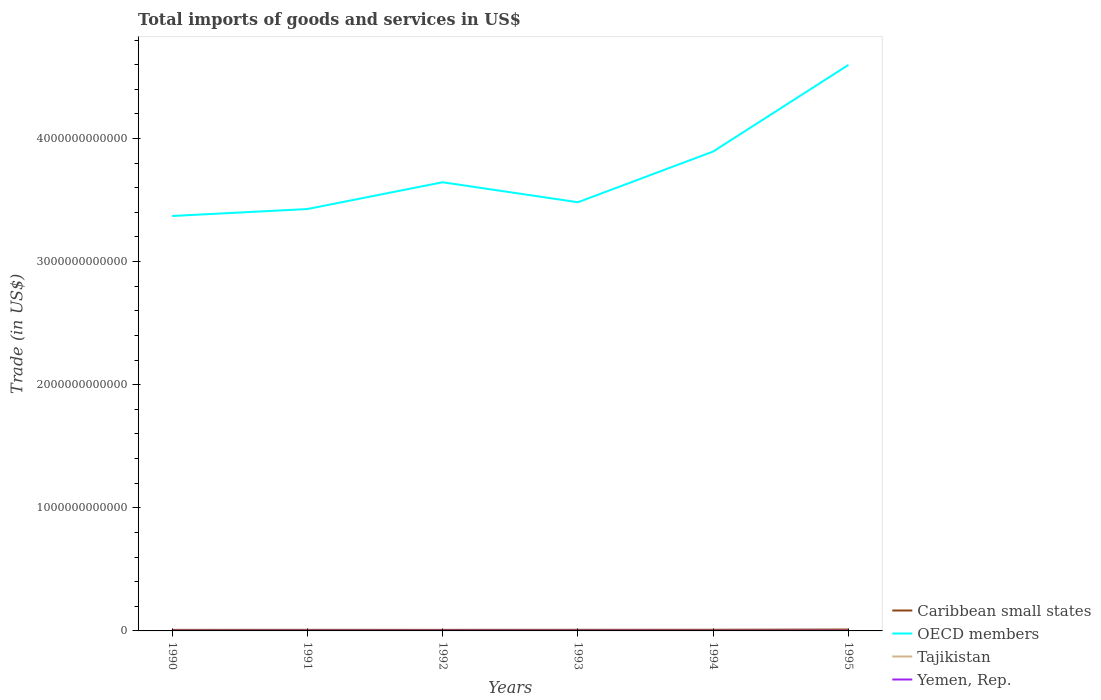Across all years, what is the maximum total imports of goods and services in OECD members?
Your answer should be very brief. 3.37e+12. What is the total total imports of goods and services in Yemen, Rep. in the graph?
Your answer should be compact. 1.48e+08. What is the difference between the highest and the second highest total imports of goods and services in Tajikistan?
Your response must be concise. 6.85e+08. Is the total imports of goods and services in Tajikistan strictly greater than the total imports of goods and services in Caribbean small states over the years?
Your response must be concise. Yes. How many lines are there?
Your answer should be very brief. 4. How many years are there in the graph?
Your answer should be compact. 6. What is the difference between two consecutive major ticks on the Y-axis?
Offer a terse response. 1.00e+12. Are the values on the major ticks of Y-axis written in scientific E-notation?
Ensure brevity in your answer.  No. Does the graph contain any zero values?
Your answer should be very brief. No. Where does the legend appear in the graph?
Keep it short and to the point. Bottom right. How many legend labels are there?
Keep it short and to the point. 4. How are the legend labels stacked?
Your answer should be very brief. Vertical. What is the title of the graph?
Give a very brief answer. Total imports of goods and services in US$. What is the label or title of the X-axis?
Give a very brief answer. Years. What is the label or title of the Y-axis?
Offer a terse response. Trade (in US$). What is the Trade (in US$) in Caribbean small states in 1990?
Offer a very short reply. 8.47e+09. What is the Trade (in US$) of OECD members in 1990?
Give a very brief answer. 3.37e+12. What is the Trade (in US$) in Tajikistan in 1990?
Your answer should be very brief. 9.25e+08. What is the Trade (in US$) of Yemen, Rep. in 1990?
Offer a very short reply. 9.69e+08. What is the Trade (in US$) in Caribbean small states in 1991?
Make the answer very short. 8.66e+09. What is the Trade (in US$) of OECD members in 1991?
Offer a terse response. 3.43e+12. What is the Trade (in US$) in Tajikistan in 1991?
Your answer should be very brief. 8.17e+08. What is the Trade (in US$) in Yemen, Rep. in 1991?
Give a very brief answer. 1.79e+09. What is the Trade (in US$) in Caribbean small states in 1992?
Give a very brief answer. 8.45e+09. What is the Trade (in US$) of OECD members in 1992?
Offer a terse response. 3.64e+12. What is the Trade (in US$) of Tajikistan in 1992?
Your answer should be very brief. 2.40e+08. What is the Trade (in US$) of Yemen, Rep. in 1992?
Make the answer very short. 1.94e+09. What is the Trade (in US$) in Caribbean small states in 1993?
Provide a short and direct response. 8.96e+09. What is the Trade (in US$) in OECD members in 1993?
Make the answer very short. 3.48e+12. What is the Trade (in US$) of Tajikistan in 1993?
Provide a short and direct response. 6.86e+08. What is the Trade (in US$) in Yemen, Rep. in 1993?
Offer a terse response. 2.05e+09. What is the Trade (in US$) of Caribbean small states in 1994?
Make the answer very short. 9.38e+09. What is the Trade (in US$) of OECD members in 1994?
Your response must be concise. 3.89e+12. What is the Trade (in US$) of Tajikistan in 1994?
Provide a succinct answer. 7.35e+08. What is the Trade (in US$) of Yemen, Rep. in 1994?
Ensure brevity in your answer.  1.22e+09. What is the Trade (in US$) of Caribbean small states in 1995?
Provide a short and direct response. 1.14e+1. What is the Trade (in US$) in OECD members in 1995?
Keep it short and to the point. 4.60e+12. What is the Trade (in US$) of Tajikistan in 1995?
Your answer should be very brief. 8.86e+08. What is the Trade (in US$) in Yemen, Rep. in 1995?
Your response must be concise. 1.79e+09. Across all years, what is the maximum Trade (in US$) in Caribbean small states?
Your answer should be compact. 1.14e+1. Across all years, what is the maximum Trade (in US$) of OECD members?
Offer a terse response. 4.60e+12. Across all years, what is the maximum Trade (in US$) of Tajikistan?
Provide a succinct answer. 9.25e+08. Across all years, what is the maximum Trade (in US$) of Yemen, Rep.?
Your answer should be compact. 2.05e+09. Across all years, what is the minimum Trade (in US$) of Caribbean small states?
Provide a succinct answer. 8.45e+09. Across all years, what is the minimum Trade (in US$) of OECD members?
Your response must be concise. 3.37e+12. Across all years, what is the minimum Trade (in US$) in Tajikistan?
Offer a very short reply. 2.40e+08. Across all years, what is the minimum Trade (in US$) in Yemen, Rep.?
Provide a short and direct response. 9.69e+08. What is the total Trade (in US$) of Caribbean small states in the graph?
Make the answer very short. 5.53e+1. What is the total Trade (in US$) of OECD members in the graph?
Ensure brevity in your answer.  2.24e+13. What is the total Trade (in US$) in Tajikistan in the graph?
Provide a succinct answer. 4.29e+09. What is the total Trade (in US$) in Yemen, Rep. in the graph?
Provide a short and direct response. 9.75e+09. What is the difference between the Trade (in US$) of Caribbean small states in 1990 and that in 1991?
Your answer should be compact. -1.87e+08. What is the difference between the Trade (in US$) in OECD members in 1990 and that in 1991?
Keep it short and to the point. -5.65e+1. What is the difference between the Trade (in US$) in Tajikistan in 1990 and that in 1991?
Your answer should be compact. 1.08e+08. What is the difference between the Trade (in US$) of Yemen, Rep. in 1990 and that in 1991?
Make the answer very short. -8.25e+08. What is the difference between the Trade (in US$) of Caribbean small states in 1990 and that in 1992?
Make the answer very short. 1.64e+07. What is the difference between the Trade (in US$) of OECD members in 1990 and that in 1992?
Provide a succinct answer. -2.74e+11. What is the difference between the Trade (in US$) of Tajikistan in 1990 and that in 1992?
Your response must be concise. 6.85e+08. What is the difference between the Trade (in US$) in Yemen, Rep. in 1990 and that in 1992?
Your answer should be compact. -9.66e+08. What is the difference between the Trade (in US$) in Caribbean small states in 1990 and that in 1993?
Offer a terse response. -4.91e+08. What is the difference between the Trade (in US$) of OECD members in 1990 and that in 1993?
Your response must be concise. -1.12e+11. What is the difference between the Trade (in US$) in Tajikistan in 1990 and that in 1993?
Keep it short and to the point. 2.39e+08. What is the difference between the Trade (in US$) in Yemen, Rep. in 1990 and that in 1993?
Ensure brevity in your answer.  -1.08e+09. What is the difference between the Trade (in US$) of Caribbean small states in 1990 and that in 1994?
Give a very brief answer. -9.08e+08. What is the difference between the Trade (in US$) in OECD members in 1990 and that in 1994?
Your answer should be compact. -5.24e+11. What is the difference between the Trade (in US$) in Tajikistan in 1990 and that in 1994?
Your answer should be very brief. 1.90e+08. What is the difference between the Trade (in US$) of Yemen, Rep. in 1990 and that in 1994?
Your answer should be compact. -2.47e+08. What is the difference between the Trade (in US$) in Caribbean small states in 1990 and that in 1995?
Ensure brevity in your answer.  -2.92e+09. What is the difference between the Trade (in US$) in OECD members in 1990 and that in 1995?
Make the answer very short. -1.23e+12. What is the difference between the Trade (in US$) of Tajikistan in 1990 and that in 1995?
Provide a short and direct response. 3.91e+07. What is the difference between the Trade (in US$) of Yemen, Rep. in 1990 and that in 1995?
Your answer should be compact. -8.18e+08. What is the difference between the Trade (in US$) in Caribbean small states in 1991 and that in 1992?
Provide a short and direct response. 2.03e+08. What is the difference between the Trade (in US$) in OECD members in 1991 and that in 1992?
Offer a very short reply. -2.18e+11. What is the difference between the Trade (in US$) in Tajikistan in 1991 and that in 1992?
Provide a succinct answer. 5.77e+08. What is the difference between the Trade (in US$) in Yemen, Rep. in 1991 and that in 1992?
Ensure brevity in your answer.  -1.41e+08. What is the difference between the Trade (in US$) of Caribbean small states in 1991 and that in 1993?
Make the answer very short. -3.04e+08. What is the difference between the Trade (in US$) of OECD members in 1991 and that in 1993?
Make the answer very short. -5.52e+1. What is the difference between the Trade (in US$) of Tajikistan in 1991 and that in 1993?
Offer a terse response. 1.31e+08. What is the difference between the Trade (in US$) in Yemen, Rep. in 1991 and that in 1993?
Provide a short and direct response. -2.58e+08. What is the difference between the Trade (in US$) in Caribbean small states in 1991 and that in 1994?
Give a very brief answer. -7.22e+08. What is the difference between the Trade (in US$) in OECD members in 1991 and that in 1994?
Give a very brief answer. -4.67e+11. What is the difference between the Trade (in US$) in Tajikistan in 1991 and that in 1994?
Your answer should be compact. 8.19e+07. What is the difference between the Trade (in US$) of Yemen, Rep. in 1991 and that in 1994?
Provide a succinct answer. 5.77e+08. What is the difference between the Trade (in US$) in Caribbean small states in 1991 and that in 1995?
Your response must be concise. -2.73e+09. What is the difference between the Trade (in US$) of OECD members in 1991 and that in 1995?
Offer a terse response. -1.17e+12. What is the difference between the Trade (in US$) in Tajikistan in 1991 and that in 1995?
Your answer should be compact. -6.88e+07. What is the difference between the Trade (in US$) in Yemen, Rep. in 1991 and that in 1995?
Offer a very short reply. 6.89e+06. What is the difference between the Trade (in US$) of Caribbean small states in 1992 and that in 1993?
Give a very brief answer. -5.07e+08. What is the difference between the Trade (in US$) of OECD members in 1992 and that in 1993?
Your answer should be very brief. 1.62e+11. What is the difference between the Trade (in US$) of Tajikistan in 1992 and that in 1993?
Your answer should be very brief. -4.46e+08. What is the difference between the Trade (in US$) of Yemen, Rep. in 1992 and that in 1993?
Provide a short and direct response. -1.16e+08. What is the difference between the Trade (in US$) in Caribbean small states in 1992 and that in 1994?
Offer a terse response. -9.25e+08. What is the difference between the Trade (in US$) in OECD members in 1992 and that in 1994?
Give a very brief answer. -2.50e+11. What is the difference between the Trade (in US$) in Tajikistan in 1992 and that in 1994?
Provide a short and direct response. -4.96e+08. What is the difference between the Trade (in US$) in Yemen, Rep. in 1992 and that in 1994?
Your answer should be very brief. 7.19e+08. What is the difference between the Trade (in US$) in Caribbean small states in 1992 and that in 1995?
Keep it short and to the point. -2.93e+09. What is the difference between the Trade (in US$) in OECD members in 1992 and that in 1995?
Your answer should be compact. -9.53e+11. What is the difference between the Trade (in US$) of Tajikistan in 1992 and that in 1995?
Provide a succinct answer. -6.46e+08. What is the difference between the Trade (in US$) of Yemen, Rep. in 1992 and that in 1995?
Make the answer very short. 1.48e+08. What is the difference between the Trade (in US$) of Caribbean small states in 1993 and that in 1994?
Offer a terse response. -4.17e+08. What is the difference between the Trade (in US$) of OECD members in 1993 and that in 1994?
Make the answer very short. -4.12e+11. What is the difference between the Trade (in US$) of Tajikistan in 1993 and that in 1994?
Offer a terse response. -4.95e+07. What is the difference between the Trade (in US$) in Yemen, Rep. in 1993 and that in 1994?
Provide a succinct answer. 8.35e+08. What is the difference between the Trade (in US$) in Caribbean small states in 1993 and that in 1995?
Offer a very short reply. -2.42e+09. What is the difference between the Trade (in US$) in OECD members in 1993 and that in 1995?
Offer a very short reply. -1.12e+12. What is the difference between the Trade (in US$) of Tajikistan in 1993 and that in 1995?
Your response must be concise. -2.00e+08. What is the difference between the Trade (in US$) of Yemen, Rep. in 1993 and that in 1995?
Your answer should be compact. 2.64e+08. What is the difference between the Trade (in US$) of Caribbean small states in 1994 and that in 1995?
Ensure brevity in your answer.  -2.01e+09. What is the difference between the Trade (in US$) of OECD members in 1994 and that in 1995?
Keep it short and to the point. -7.04e+11. What is the difference between the Trade (in US$) in Tajikistan in 1994 and that in 1995?
Make the answer very short. -1.51e+08. What is the difference between the Trade (in US$) of Yemen, Rep. in 1994 and that in 1995?
Ensure brevity in your answer.  -5.71e+08. What is the difference between the Trade (in US$) of Caribbean small states in 1990 and the Trade (in US$) of OECD members in 1991?
Make the answer very short. -3.42e+12. What is the difference between the Trade (in US$) of Caribbean small states in 1990 and the Trade (in US$) of Tajikistan in 1991?
Offer a terse response. 7.65e+09. What is the difference between the Trade (in US$) of Caribbean small states in 1990 and the Trade (in US$) of Yemen, Rep. in 1991?
Your response must be concise. 6.68e+09. What is the difference between the Trade (in US$) in OECD members in 1990 and the Trade (in US$) in Tajikistan in 1991?
Make the answer very short. 3.37e+12. What is the difference between the Trade (in US$) in OECD members in 1990 and the Trade (in US$) in Yemen, Rep. in 1991?
Ensure brevity in your answer.  3.37e+12. What is the difference between the Trade (in US$) of Tajikistan in 1990 and the Trade (in US$) of Yemen, Rep. in 1991?
Your answer should be compact. -8.69e+08. What is the difference between the Trade (in US$) of Caribbean small states in 1990 and the Trade (in US$) of OECD members in 1992?
Your answer should be very brief. -3.64e+12. What is the difference between the Trade (in US$) in Caribbean small states in 1990 and the Trade (in US$) in Tajikistan in 1992?
Ensure brevity in your answer.  8.23e+09. What is the difference between the Trade (in US$) of Caribbean small states in 1990 and the Trade (in US$) of Yemen, Rep. in 1992?
Provide a succinct answer. 6.54e+09. What is the difference between the Trade (in US$) in OECD members in 1990 and the Trade (in US$) in Tajikistan in 1992?
Make the answer very short. 3.37e+12. What is the difference between the Trade (in US$) of OECD members in 1990 and the Trade (in US$) of Yemen, Rep. in 1992?
Provide a short and direct response. 3.37e+12. What is the difference between the Trade (in US$) in Tajikistan in 1990 and the Trade (in US$) in Yemen, Rep. in 1992?
Ensure brevity in your answer.  -1.01e+09. What is the difference between the Trade (in US$) in Caribbean small states in 1990 and the Trade (in US$) in OECD members in 1993?
Give a very brief answer. -3.47e+12. What is the difference between the Trade (in US$) of Caribbean small states in 1990 and the Trade (in US$) of Tajikistan in 1993?
Offer a terse response. 7.79e+09. What is the difference between the Trade (in US$) of Caribbean small states in 1990 and the Trade (in US$) of Yemen, Rep. in 1993?
Offer a very short reply. 6.42e+09. What is the difference between the Trade (in US$) of OECD members in 1990 and the Trade (in US$) of Tajikistan in 1993?
Provide a succinct answer. 3.37e+12. What is the difference between the Trade (in US$) in OECD members in 1990 and the Trade (in US$) in Yemen, Rep. in 1993?
Give a very brief answer. 3.37e+12. What is the difference between the Trade (in US$) of Tajikistan in 1990 and the Trade (in US$) of Yemen, Rep. in 1993?
Keep it short and to the point. -1.13e+09. What is the difference between the Trade (in US$) of Caribbean small states in 1990 and the Trade (in US$) of OECD members in 1994?
Offer a terse response. -3.89e+12. What is the difference between the Trade (in US$) in Caribbean small states in 1990 and the Trade (in US$) in Tajikistan in 1994?
Your response must be concise. 7.74e+09. What is the difference between the Trade (in US$) of Caribbean small states in 1990 and the Trade (in US$) of Yemen, Rep. in 1994?
Provide a succinct answer. 7.26e+09. What is the difference between the Trade (in US$) in OECD members in 1990 and the Trade (in US$) in Tajikistan in 1994?
Make the answer very short. 3.37e+12. What is the difference between the Trade (in US$) in OECD members in 1990 and the Trade (in US$) in Yemen, Rep. in 1994?
Ensure brevity in your answer.  3.37e+12. What is the difference between the Trade (in US$) in Tajikistan in 1990 and the Trade (in US$) in Yemen, Rep. in 1994?
Provide a short and direct response. -2.91e+08. What is the difference between the Trade (in US$) in Caribbean small states in 1990 and the Trade (in US$) in OECD members in 1995?
Your answer should be compact. -4.59e+12. What is the difference between the Trade (in US$) of Caribbean small states in 1990 and the Trade (in US$) of Tajikistan in 1995?
Ensure brevity in your answer.  7.59e+09. What is the difference between the Trade (in US$) in Caribbean small states in 1990 and the Trade (in US$) in Yemen, Rep. in 1995?
Keep it short and to the point. 6.68e+09. What is the difference between the Trade (in US$) in OECD members in 1990 and the Trade (in US$) in Tajikistan in 1995?
Keep it short and to the point. 3.37e+12. What is the difference between the Trade (in US$) of OECD members in 1990 and the Trade (in US$) of Yemen, Rep. in 1995?
Ensure brevity in your answer.  3.37e+12. What is the difference between the Trade (in US$) in Tajikistan in 1990 and the Trade (in US$) in Yemen, Rep. in 1995?
Your answer should be very brief. -8.62e+08. What is the difference between the Trade (in US$) in Caribbean small states in 1991 and the Trade (in US$) in OECD members in 1992?
Give a very brief answer. -3.64e+12. What is the difference between the Trade (in US$) in Caribbean small states in 1991 and the Trade (in US$) in Tajikistan in 1992?
Your answer should be very brief. 8.42e+09. What is the difference between the Trade (in US$) of Caribbean small states in 1991 and the Trade (in US$) of Yemen, Rep. in 1992?
Offer a terse response. 6.72e+09. What is the difference between the Trade (in US$) in OECD members in 1991 and the Trade (in US$) in Tajikistan in 1992?
Your answer should be very brief. 3.43e+12. What is the difference between the Trade (in US$) of OECD members in 1991 and the Trade (in US$) of Yemen, Rep. in 1992?
Keep it short and to the point. 3.43e+12. What is the difference between the Trade (in US$) in Tajikistan in 1991 and the Trade (in US$) in Yemen, Rep. in 1992?
Provide a succinct answer. -1.12e+09. What is the difference between the Trade (in US$) of Caribbean small states in 1991 and the Trade (in US$) of OECD members in 1993?
Keep it short and to the point. -3.47e+12. What is the difference between the Trade (in US$) in Caribbean small states in 1991 and the Trade (in US$) in Tajikistan in 1993?
Offer a very short reply. 7.97e+09. What is the difference between the Trade (in US$) of Caribbean small states in 1991 and the Trade (in US$) of Yemen, Rep. in 1993?
Provide a short and direct response. 6.61e+09. What is the difference between the Trade (in US$) of OECD members in 1991 and the Trade (in US$) of Tajikistan in 1993?
Make the answer very short. 3.43e+12. What is the difference between the Trade (in US$) of OECD members in 1991 and the Trade (in US$) of Yemen, Rep. in 1993?
Ensure brevity in your answer.  3.42e+12. What is the difference between the Trade (in US$) in Tajikistan in 1991 and the Trade (in US$) in Yemen, Rep. in 1993?
Keep it short and to the point. -1.23e+09. What is the difference between the Trade (in US$) in Caribbean small states in 1991 and the Trade (in US$) in OECD members in 1994?
Offer a very short reply. -3.89e+12. What is the difference between the Trade (in US$) of Caribbean small states in 1991 and the Trade (in US$) of Tajikistan in 1994?
Provide a short and direct response. 7.92e+09. What is the difference between the Trade (in US$) in Caribbean small states in 1991 and the Trade (in US$) in Yemen, Rep. in 1994?
Your answer should be compact. 7.44e+09. What is the difference between the Trade (in US$) in OECD members in 1991 and the Trade (in US$) in Tajikistan in 1994?
Offer a very short reply. 3.43e+12. What is the difference between the Trade (in US$) of OECD members in 1991 and the Trade (in US$) of Yemen, Rep. in 1994?
Keep it short and to the point. 3.43e+12. What is the difference between the Trade (in US$) of Tajikistan in 1991 and the Trade (in US$) of Yemen, Rep. in 1994?
Your response must be concise. -3.99e+08. What is the difference between the Trade (in US$) of Caribbean small states in 1991 and the Trade (in US$) of OECD members in 1995?
Your answer should be compact. -4.59e+12. What is the difference between the Trade (in US$) of Caribbean small states in 1991 and the Trade (in US$) of Tajikistan in 1995?
Your answer should be compact. 7.77e+09. What is the difference between the Trade (in US$) in Caribbean small states in 1991 and the Trade (in US$) in Yemen, Rep. in 1995?
Ensure brevity in your answer.  6.87e+09. What is the difference between the Trade (in US$) in OECD members in 1991 and the Trade (in US$) in Tajikistan in 1995?
Provide a succinct answer. 3.43e+12. What is the difference between the Trade (in US$) in OECD members in 1991 and the Trade (in US$) in Yemen, Rep. in 1995?
Ensure brevity in your answer.  3.43e+12. What is the difference between the Trade (in US$) of Tajikistan in 1991 and the Trade (in US$) of Yemen, Rep. in 1995?
Offer a very short reply. -9.70e+08. What is the difference between the Trade (in US$) in Caribbean small states in 1992 and the Trade (in US$) in OECD members in 1993?
Provide a succinct answer. -3.47e+12. What is the difference between the Trade (in US$) in Caribbean small states in 1992 and the Trade (in US$) in Tajikistan in 1993?
Offer a terse response. 7.77e+09. What is the difference between the Trade (in US$) of Caribbean small states in 1992 and the Trade (in US$) of Yemen, Rep. in 1993?
Provide a short and direct response. 6.40e+09. What is the difference between the Trade (in US$) of OECD members in 1992 and the Trade (in US$) of Tajikistan in 1993?
Offer a terse response. 3.64e+12. What is the difference between the Trade (in US$) of OECD members in 1992 and the Trade (in US$) of Yemen, Rep. in 1993?
Your answer should be very brief. 3.64e+12. What is the difference between the Trade (in US$) of Tajikistan in 1992 and the Trade (in US$) of Yemen, Rep. in 1993?
Provide a short and direct response. -1.81e+09. What is the difference between the Trade (in US$) of Caribbean small states in 1992 and the Trade (in US$) of OECD members in 1994?
Your answer should be very brief. -3.89e+12. What is the difference between the Trade (in US$) in Caribbean small states in 1992 and the Trade (in US$) in Tajikistan in 1994?
Offer a very short reply. 7.72e+09. What is the difference between the Trade (in US$) of Caribbean small states in 1992 and the Trade (in US$) of Yemen, Rep. in 1994?
Offer a very short reply. 7.24e+09. What is the difference between the Trade (in US$) of OECD members in 1992 and the Trade (in US$) of Tajikistan in 1994?
Provide a short and direct response. 3.64e+12. What is the difference between the Trade (in US$) in OECD members in 1992 and the Trade (in US$) in Yemen, Rep. in 1994?
Keep it short and to the point. 3.64e+12. What is the difference between the Trade (in US$) of Tajikistan in 1992 and the Trade (in US$) of Yemen, Rep. in 1994?
Offer a very short reply. -9.77e+08. What is the difference between the Trade (in US$) in Caribbean small states in 1992 and the Trade (in US$) in OECD members in 1995?
Ensure brevity in your answer.  -4.59e+12. What is the difference between the Trade (in US$) of Caribbean small states in 1992 and the Trade (in US$) of Tajikistan in 1995?
Offer a terse response. 7.57e+09. What is the difference between the Trade (in US$) in Caribbean small states in 1992 and the Trade (in US$) in Yemen, Rep. in 1995?
Offer a very short reply. 6.67e+09. What is the difference between the Trade (in US$) in OECD members in 1992 and the Trade (in US$) in Tajikistan in 1995?
Provide a short and direct response. 3.64e+12. What is the difference between the Trade (in US$) of OECD members in 1992 and the Trade (in US$) of Yemen, Rep. in 1995?
Your answer should be very brief. 3.64e+12. What is the difference between the Trade (in US$) in Tajikistan in 1992 and the Trade (in US$) in Yemen, Rep. in 1995?
Offer a terse response. -1.55e+09. What is the difference between the Trade (in US$) in Caribbean small states in 1993 and the Trade (in US$) in OECD members in 1994?
Offer a terse response. -3.89e+12. What is the difference between the Trade (in US$) in Caribbean small states in 1993 and the Trade (in US$) in Tajikistan in 1994?
Make the answer very short. 8.23e+09. What is the difference between the Trade (in US$) of Caribbean small states in 1993 and the Trade (in US$) of Yemen, Rep. in 1994?
Give a very brief answer. 7.75e+09. What is the difference between the Trade (in US$) in OECD members in 1993 and the Trade (in US$) in Tajikistan in 1994?
Your response must be concise. 3.48e+12. What is the difference between the Trade (in US$) of OECD members in 1993 and the Trade (in US$) of Yemen, Rep. in 1994?
Your answer should be compact. 3.48e+12. What is the difference between the Trade (in US$) of Tajikistan in 1993 and the Trade (in US$) of Yemen, Rep. in 1994?
Keep it short and to the point. -5.31e+08. What is the difference between the Trade (in US$) of Caribbean small states in 1993 and the Trade (in US$) of OECD members in 1995?
Provide a succinct answer. -4.59e+12. What is the difference between the Trade (in US$) of Caribbean small states in 1993 and the Trade (in US$) of Tajikistan in 1995?
Keep it short and to the point. 8.08e+09. What is the difference between the Trade (in US$) in Caribbean small states in 1993 and the Trade (in US$) in Yemen, Rep. in 1995?
Give a very brief answer. 7.18e+09. What is the difference between the Trade (in US$) in OECD members in 1993 and the Trade (in US$) in Tajikistan in 1995?
Provide a short and direct response. 3.48e+12. What is the difference between the Trade (in US$) of OECD members in 1993 and the Trade (in US$) of Yemen, Rep. in 1995?
Your response must be concise. 3.48e+12. What is the difference between the Trade (in US$) of Tajikistan in 1993 and the Trade (in US$) of Yemen, Rep. in 1995?
Offer a terse response. -1.10e+09. What is the difference between the Trade (in US$) in Caribbean small states in 1994 and the Trade (in US$) in OECD members in 1995?
Your response must be concise. -4.59e+12. What is the difference between the Trade (in US$) in Caribbean small states in 1994 and the Trade (in US$) in Tajikistan in 1995?
Your response must be concise. 8.49e+09. What is the difference between the Trade (in US$) in Caribbean small states in 1994 and the Trade (in US$) in Yemen, Rep. in 1995?
Your response must be concise. 7.59e+09. What is the difference between the Trade (in US$) of OECD members in 1994 and the Trade (in US$) of Tajikistan in 1995?
Ensure brevity in your answer.  3.89e+12. What is the difference between the Trade (in US$) in OECD members in 1994 and the Trade (in US$) in Yemen, Rep. in 1995?
Offer a terse response. 3.89e+12. What is the difference between the Trade (in US$) in Tajikistan in 1994 and the Trade (in US$) in Yemen, Rep. in 1995?
Your answer should be very brief. -1.05e+09. What is the average Trade (in US$) in Caribbean small states per year?
Provide a succinct answer. 9.22e+09. What is the average Trade (in US$) in OECD members per year?
Offer a very short reply. 3.74e+12. What is the average Trade (in US$) of Tajikistan per year?
Keep it short and to the point. 7.15e+08. What is the average Trade (in US$) in Yemen, Rep. per year?
Provide a short and direct response. 1.63e+09. In the year 1990, what is the difference between the Trade (in US$) of Caribbean small states and Trade (in US$) of OECD members?
Provide a succinct answer. -3.36e+12. In the year 1990, what is the difference between the Trade (in US$) of Caribbean small states and Trade (in US$) of Tajikistan?
Your response must be concise. 7.55e+09. In the year 1990, what is the difference between the Trade (in US$) of Caribbean small states and Trade (in US$) of Yemen, Rep.?
Your response must be concise. 7.50e+09. In the year 1990, what is the difference between the Trade (in US$) of OECD members and Trade (in US$) of Tajikistan?
Your answer should be very brief. 3.37e+12. In the year 1990, what is the difference between the Trade (in US$) of OECD members and Trade (in US$) of Yemen, Rep.?
Make the answer very short. 3.37e+12. In the year 1990, what is the difference between the Trade (in US$) of Tajikistan and Trade (in US$) of Yemen, Rep.?
Your answer should be very brief. -4.42e+07. In the year 1991, what is the difference between the Trade (in US$) of Caribbean small states and Trade (in US$) of OECD members?
Make the answer very short. -3.42e+12. In the year 1991, what is the difference between the Trade (in US$) of Caribbean small states and Trade (in US$) of Tajikistan?
Provide a short and direct response. 7.84e+09. In the year 1991, what is the difference between the Trade (in US$) of Caribbean small states and Trade (in US$) of Yemen, Rep.?
Provide a succinct answer. 6.86e+09. In the year 1991, what is the difference between the Trade (in US$) of OECD members and Trade (in US$) of Tajikistan?
Give a very brief answer. 3.43e+12. In the year 1991, what is the difference between the Trade (in US$) of OECD members and Trade (in US$) of Yemen, Rep.?
Your answer should be very brief. 3.43e+12. In the year 1991, what is the difference between the Trade (in US$) in Tajikistan and Trade (in US$) in Yemen, Rep.?
Give a very brief answer. -9.77e+08. In the year 1992, what is the difference between the Trade (in US$) in Caribbean small states and Trade (in US$) in OECD members?
Ensure brevity in your answer.  -3.64e+12. In the year 1992, what is the difference between the Trade (in US$) in Caribbean small states and Trade (in US$) in Tajikistan?
Make the answer very short. 8.22e+09. In the year 1992, what is the difference between the Trade (in US$) in Caribbean small states and Trade (in US$) in Yemen, Rep.?
Provide a succinct answer. 6.52e+09. In the year 1992, what is the difference between the Trade (in US$) in OECD members and Trade (in US$) in Tajikistan?
Offer a very short reply. 3.64e+12. In the year 1992, what is the difference between the Trade (in US$) of OECD members and Trade (in US$) of Yemen, Rep.?
Give a very brief answer. 3.64e+12. In the year 1992, what is the difference between the Trade (in US$) of Tajikistan and Trade (in US$) of Yemen, Rep.?
Make the answer very short. -1.70e+09. In the year 1993, what is the difference between the Trade (in US$) of Caribbean small states and Trade (in US$) of OECD members?
Keep it short and to the point. -3.47e+12. In the year 1993, what is the difference between the Trade (in US$) of Caribbean small states and Trade (in US$) of Tajikistan?
Give a very brief answer. 8.28e+09. In the year 1993, what is the difference between the Trade (in US$) of Caribbean small states and Trade (in US$) of Yemen, Rep.?
Your answer should be very brief. 6.91e+09. In the year 1993, what is the difference between the Trade (in US$) in OECD members and Trade (in US$) in Tajikistan?
Your answer should be compact. 3.48e+12. In the year 1993, what is the difference between the Trade (in US$) of OECD members and Trade (in US$) of Yemen, Rep.?
Your answer should be compact. 3.48e+12. In the year 1993, what is the difference between the Trade (in US$) in Tajikistan and Trade (in US$) in Yemen, Rep.?
Provide a succinct answer. -1.37e+09. In the year 1994, what is the difference between the Trade (in US$) in Caribbean small states and Trade (in US$) in OECD members?
Provide a short and direct response. -3.89e+12. In the year 1994, what is the difference between the Trade (in US$) in Caribbean small states and Trade (in US$) in Tajikistan?
Your answer should be compact. 8.64e+09. In the year 1994, what is the difference between the Trade (in US$) of Caribbean small states and Trade (in US$) of Yemen, Rep.?
Make the answer very short. 8.16e+09. In the year 1994, what is the difference between the Trade (in US$) in OECD members and Trade (in US$) in Tajikistan?
Give a very brief answer. 3.89e+12. In the year 1994, what is the difference between the Trade (in US$) of OECD members and Trade (in US$) of Yemen, Rep.?
Provide a short and direct response. 3.89e+12. In the year 1994, what is the difference between the Trade (in US$) of Tajikistan and Trade (in US$) of Yemen, Rep.?
Your answer should be compact. -4.81e+08. In the year 1995, what is the difference between the Trade (in US$) of Caribbean small states and Trade (in US$) of OECD members?
Provide a succinct answer. -4.59e+12. In the year 1995, what is the difference between the Trade (in US$) in Caribbean small states and Trade (in US$) in Tajikistan?
Your answer should be compact. 1.05e+1. In the year 1995, what is the difference between the Trade (in US$) of Caribbean small states and Trade (in US$) of Yemen, Rep.?
Offer a terse response. 9.60e+09. In the year 1995, what is the difference between the Trade (in US$) in OECD members and Trade (in US$) in Tajikistan?
Your answer should be very brief. 4.60e+12. In the year 1995, what is the difference between the Trade (in US$) in OECD members and Trade (in US$) in Yemen, Rep.?
Your answer should be compact. 4.60e+12. In the year 1995, what is the difference between the Trade (in US$) of Tajikistan and Trade (in US$) of Yemen, Rep.?
Keep it short and to the point. -9.01e+08. What is the ratio of the Trade (in US$) of Caribbean small states in 1990 to that in 1991?
Your answer should be compact. 0.98. What is the ratio of the Trade (in US$) of OECD members in 1990 to that in 1991?
Offer a terse response. 0.98. What is the ratio of the Trade (in US$) in Tajikistan in 1990 to that in 1991?
Make the answer very short. 1.13. What is the ratio of the Trade (in US$) of Yemen, Rep. in 1990 to that in 1991?
Ensure brevity in your answer.  0.54. What is the ratio of the Trade (in US$) in Caribbean small states in 1990 to that in 1992?
Provide a short and direct response. 1. What is the ratio of the Trade (in US$) of OECD members in 1990 to that in 1992?
Keep it short and to the point. 0.92. What is the ratio of the Trade (in US$) in Tajikistan in 1990 to that in 1992?
Provide a succinct answer. 3.86. What is the ratio of the Trade (in US$) in Yemen, Rep. in 1990 to that in 1992?
Ensure brevity in your answer.  0.5. What is the ratio of the Trade (in US$) of Caribbean small states in 1990 to that in 1993?
Provide a succinct answer. 0.95. What is the ratio of the Trade (in US$) of OECD members in 1990 to that in 1993?
Ensure brevity in your answer.  0.97. What is the ratio of the Trade (in US$) in Tajikistan in 1990 to that in 1993?
Provide a succinct answer. 1.35. What is the ratio of the Trade (in US$) of Yemen, Rep. in 1990 to that in 1993?
Ensure brevity in your answer.  0.47. What is the ratio of the Trade (in US$) of Caribbean small states in 1990 to that in 1994?
Offer a terse response. 0.9. What is the ratio of the Trade (in US$) of OECD members in 1990 to that in 1994?
Keep it short and to the point. 0.87. What is the ratio of the Trade (in US$) of Tajikistan in 1990 to that in 1994?
Ensure brevity in your answer.  1.26. What is the ratio of the Trade (in US$) in Yemen, Rep. in 1990 to that in 1994?
Provide a short and direct response. 0.8. What is the ratio of the Trade (in US$) of Caribbean small states in 1990 to that in 1995?
Your response must be concise. 0.74. What is the ratio of the Trade (in US$) of OECD members in 1990 to that in 1995?
Your answer should be very brief. 0.73. What is the ratio of the Trade (in US$) in Tajikistan in 1990 to that in 1995?
Make the answer very short. 1.04. What is the ratio of the Trade (in US$) in Yemen, Rep. in 1990 to that in 1995?
Offer a very short reply. 0.54. What is the ratio of the Trade (in US$) of Caribbean small states in 1991 to that in 1992?
Your response must be concise. 1.02. What is the ratio of the Trade (in US$) in OECD members in 1991 to that in 1992?
Your answer should be very brief. 0.94. What is the ratio of the Trade (in US$) in Tajikistan in 1991 to that in 1992?
Make the answer very short. 3.41. What is the ratio of the Trade (in US$) of Yemen, Rep. in 1991 to that in 1992?
Keep it short and to the point. 0.93. What is the ratio of the Trade (in US$) in Caribbean small states in 1991 to that in 1993?
Offer a terse response. 0.97. What is the ratio of the Trade (in US$) in OECD members in 1991 to that in 1993?
Your answer should be very brief. 0.98. What is the ratio of the Trade (in US$) in Tajikistan in 1991 to that in 1993?
Keep it short and to the point. 1.19. What is the ratio of the Trade (in US$) of Yemen, Rep. in 1991 to that in 1993?
Your answer should be compact. 0.87. What is the ratio of the Trade (in US$) of Caribbean small states in 1991 to that in 1994?
Offer a very short reply. 0.92. What is the ratio of the Trade (in US$) in OECD members in 1991 to that in 1994?
Provide a succinct answer. 0.88. What is the ratio of the Trade (in US$) of Tajikistan in 1991 to that in 1994?
Provide a succinct answer. 1.11. What is the ratio of the Trade (in US$) in Yemen, Rep. in 1991 to that in 1994?
Offer a very short reply. 1.47. What is the ratio of the Trade (in US$) of Caribbean small states in 1991 to that in 1995?
Your answer should be compact. 0.76. What is the ratio of the Trade (in US$) in OECD members in 1991 to that in 1995?
Offer a very short reply. 0.75. What is the ratio of the Trade (in US$) of Tajikistan in 1991 to that in 1995?
Make the answer very short. 0.92. What is the ratio of the Trade (in US$) of Caribbean small states in 1992 to that in 1993?
Your answer should be compact. 0.94. What is the ratio of the Trade (in US$) of OECD members in 1992 to that in 1993?
Your answer should be very brief. 1.05. What is the ratio of the Trade (in US$) of Tajikistan in 1992 to that in 1993?
Offer a very short reply. 0.35. What is the ratio of the Trade (in US$) in Yemen, Rep. in 1992 to that in 1993?
Give a very brief answer. 0.94. What is the ratio of the Trade (in US$) of Caribbean small states in 1992 to that in 1994?
Provide a succinct answer. 0.9. What is the ratio of the Trade (in US$) of OECD members in 1992 to that in 1994?
Provide a succinct answer. 0.94. What is the ratio of the Trade (in US$) in Tajikistan in 1992 to that in 1994?
Give a very brief answer. 0.33. What is the ratio of the Trade (in US$) of Yemen, Rep. in 1992 to that in 1994?
Make the answer very short. 1.59. What is the ratio of the Trade (in US$) in Caribbean small states in 1992 to that in 1995?
Ensure brevity in your answer.  0.74. What is the ratio of the Trade (in US$) of OECD members in 1992 to that in 1995?
Keep it short and to the point. 0.79. What is the ratio of the Trade (in US$) of Tajikistan in 1992 to that in 1995?
Make the answer very short. 0.27. What is the ratio of the Trade (in US$) in Yemen, Rep. in 1992 to that in 1995?
Make the answer very short. 1.08. What is the ratio of the Trade (in US$) in Caribbean small states in 1993 to that in 1994?
Your answer should be compact. 0.96. What is the ratio of the Trade (in US$) in OECD members in 1993 to that in 1994?
Provide a succinct answer. 0.89. What is the ratio of the Trade (in US$) of Tajikistan in 1993 to that in 1994?
Your answer should be very brief. 0.93. What is the ratio of the Trade (in US$) of Yemen, Rep. in 1993 to that in 1994?
Offer a very short reply. 1.69. What is the ratio of the Trade (in US$) of Caribbean small states in 1993 to that in 1995?
Offer a very short reply. 0.79. What is the ratio of the Trade (in US$) of OECD members in 1993 to that in 1995?
Provide a succinct answer. 0.76. What is the ratio of the Trade (in US$) of Tajikistan in 1993 to that in 1995?
Your answer should be very brief. 0.77. What is the ratio of the Trade (in US$) in Yemen, Rep. in 1993 to that in 1995?
Offer a terse response. 1.15. What is the ratio of the Trade (in US$) of Caribbean small states in 1994 to that in 1995?
Your answer should be compact. 0.82. What is the ratio of the Trade (in US$) of OECD members in 1994 to that in 1995?
Ensure brevity in your answer.  0.85. What is the ratio of the Trade (in US$) of Tajikistan in 1994 to that in 1995?
Your response must be concise. 0.83. What is the ratio of the Trade (in US$) of Yemen, Rep. in 1994 to that in 1995?
Offer a very short reply. 0.68. What is the difference between the highest and the second highest Trade (in US$) in Caribbean small states?
Offer a terse response. 2.01e+09. What is the difference between the highest and the second highest Trade (in US$) of OECD members?
Give a very brief answer. 7.04e+11. What is the difference between the highest and the second highest Trade (in US$) of Tajikistan?
Make the answer very short. 3.91e+07. What is the difference between the highest and the second highest Trade (in US$) of Yemen, Rep.?
Provide a succinct answer. 1.16e+08. What is the difference between the highest and the lowest Trade (in US$) in Caribbean small states?
Offer a very short reply. 2.93e+09. What is the difference between the highest and the lowest Trade (in US$) in OECD members?
Provide a short and direct response. 1.23e+12. What is the difference between the highest and the lowest Trade (in US$) in Tajikistan?
Offer a terse response. 6.85e+08. What is the difference between the highest and the lowest Trade (in US$) of Yemen, Rep.?
Make the answer very short. 1.08e+09. 